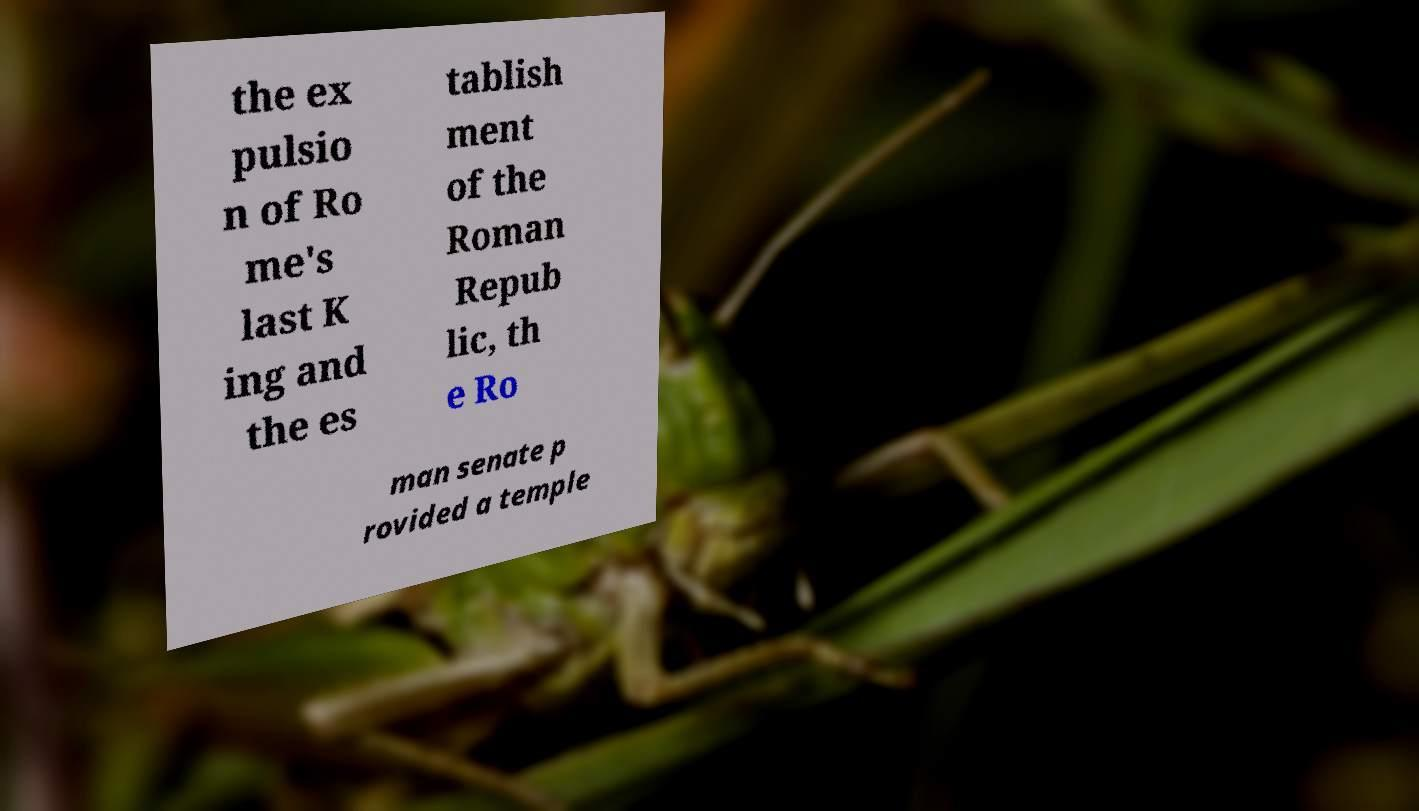Could you assist in decoding the text presented in this image and type it out clearly? the ex pulsio n of Ro me's last K ing and the es tablish ment of the Roman Repub lic, th e Ro man senate p rovided a temple 